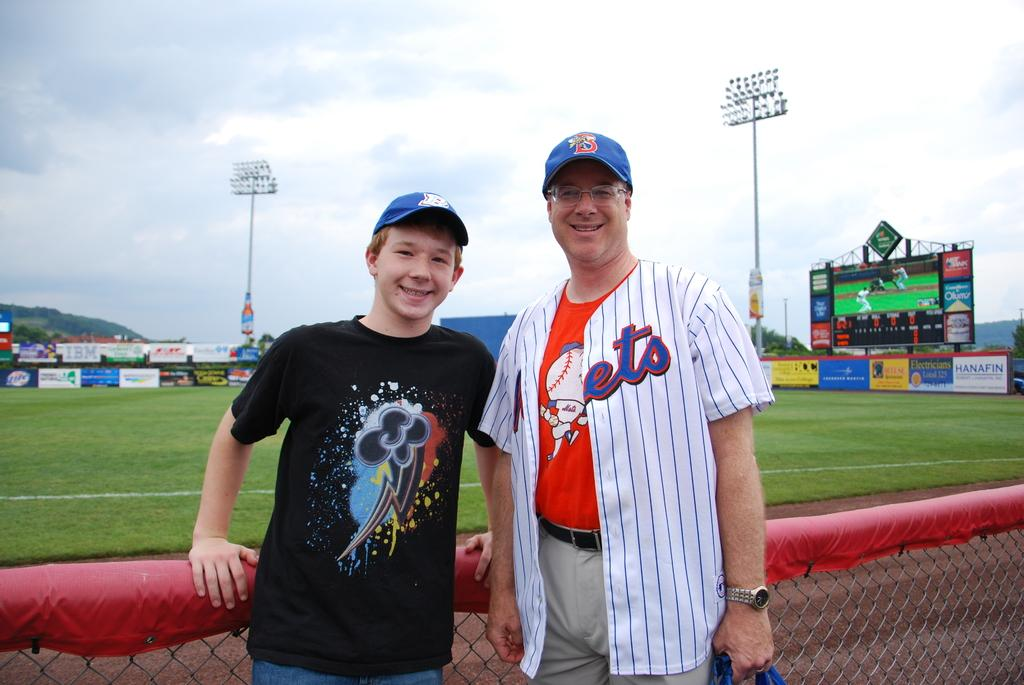<image>
Create a compact narrative representing the image presented. A man with the letters "ets" on his shirt and a boy infront of a baseball field 